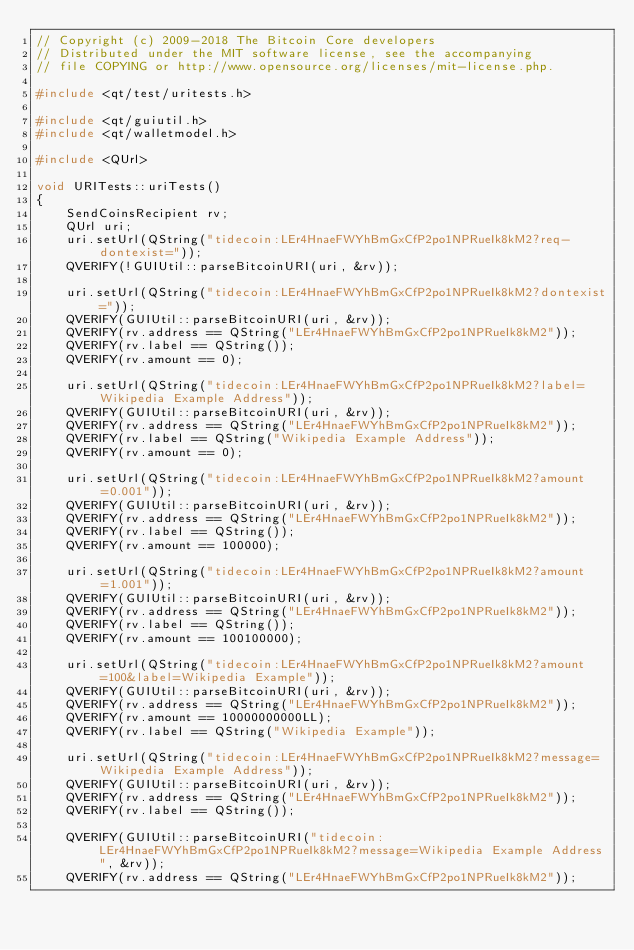Convert code to text. <code><loc_0><loc_0><loc_500><loc_500><_C++_>// Copyright (c) 2009-2018 The Bitcoin Core developers
// Distributed under the MIT software license, see the accompanying
// file COPYING or http://www.opensource.org/licenses/mit-license.php.

#include <qt/test/uritests.h>

#include <qt/guiutil.h>
#include <qt/walletmodel.h>

#include <QUrl>

void URITests::uriTests()
{
    SendCoinsRecipient rv;
    QUrl uri;
    uri.setUrl(QString("tidecoin:LEr4HnaeFWYhBmGxCfP2po1NPRueIk8kM2?req-dontexist="));
    QVERIFY(!GUIUtil::parseBitcoinURI(uri, &rv));

    uri.setUrl(QString("tidecoin:LEr4HnaeFWYhBmGxCfP2po1NPRueIk8kM2?dontexist="));
    QVERIFY(GUIUtil::parseBitcoinURI(uri, &rv));
    QVERIFY(rv.address == QString("LEr4HnaeFWYhBmGxCfP2po1NPRueIk8kM2"));
    QVERIFY(rv.label == QString());
    QVERIFY(rv.amount == 0);

    uri.setUrl(QString("tidecoin:LEr4HnaeFWYhBmGxCfP2po1NPRueIk8kM2?label=Wikipedia Example Address"));
    QVERIFY(GUIUtil::parseBitcoinURI(uri, &rv));
    QVERIFY(rv.address == QString("LEr4HnaeFWYhBmGxCfP2po1NPRueIk8kM2"));
    QVERIFY(rv.label == QString("Wikipedia Example Address"));
    QVERIFY(rv.amount == 0);

    uri.setUrl(QString("tidecoin:LEr4HnaeFWYhBmGxCfP2po1NPRueIk8kM2?amount=0.001"));
    QVERIFY(GUIUtil::parseBitcoinURI(uri, &rv));
    QVERIFY(rv.address == QString("LEr4HnaeFWYhBmGxCfP2po1NPRueIk8kM2"));
    QVERIFY(rv.label == QString());
    QVERIFY(rv.amount == 100000);

    uri.setUrl(QString("tidecoin:LEr4HnaeFWYhBmGxCfP2po1NPRueIk8kM2?amount=1.001"));
    QVERIFY(GUIUtil::parseBitcoinURI(uri, &rv));
    QVERIFY(rv.address == QString("LEr4HnaeFWYhBmGxCfP2po1NPRueIk8kM2"));
    QVERIFY(rv.label == QString());
    QVERIFY(rv.amount == 100100000);

    uri.setUrl(QString("tidecoin:LEr4HnaeFWYhBmGxCfP2po1NPRueIk8kM2?amount=100&label=Wikipedia Example"));
    QVERIFY(GUIUtil::parseBitcoinURI(uri, &rv));
    QVERIFY(rv.address == QString("LEr4HnaeFWYhBmGxCfP2po1NPRueIk8kM2"));
    QVERIFY(rv.amount == 10000000000LL);
    QVERIFY(rv.label == QString("Wikipedia Example"));

    uri.setUrl(QString("tidecoin:LEr4HnaeFWYhBmGxCfP2po1NPRueIk8kM2?message=Wikipedia Example Address"));
    QVERIFY(GUIUtil::parseBitcoinURI(uri, &rv));
    QVERIFY(rv.address == QString("LEr4HnaeFWYhBmGxCfP2po1NPRueIk8kM2"));
    QVERIFY(rv.label == QString());

    QVERIFY(GUIUtil::parseBitcoinURI("tidecoin:LEr4HnaeFWYhBmGxCfP2po1NPRueIk8kM2?message=Wikipedia Example Address", &rv));
    QVERIFY(rv.address == QString("LEr4HnaeFWYhBmGxCfP2po1NPRueIk8kM2"));</code> 